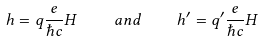Convert formula to latex. <formula><loc_0><loc_0><loc_500><loc_500>h = q \frac { e } { \hbar { c } } H \quad a n d \quad h ^ { \prime } = q ^ { \prime } \frac { e } { \hbar { c } } H</formula> 